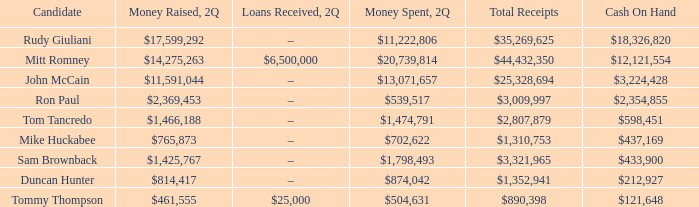What is the total amount of funds collected by tom tancredo? $2,807,879. 